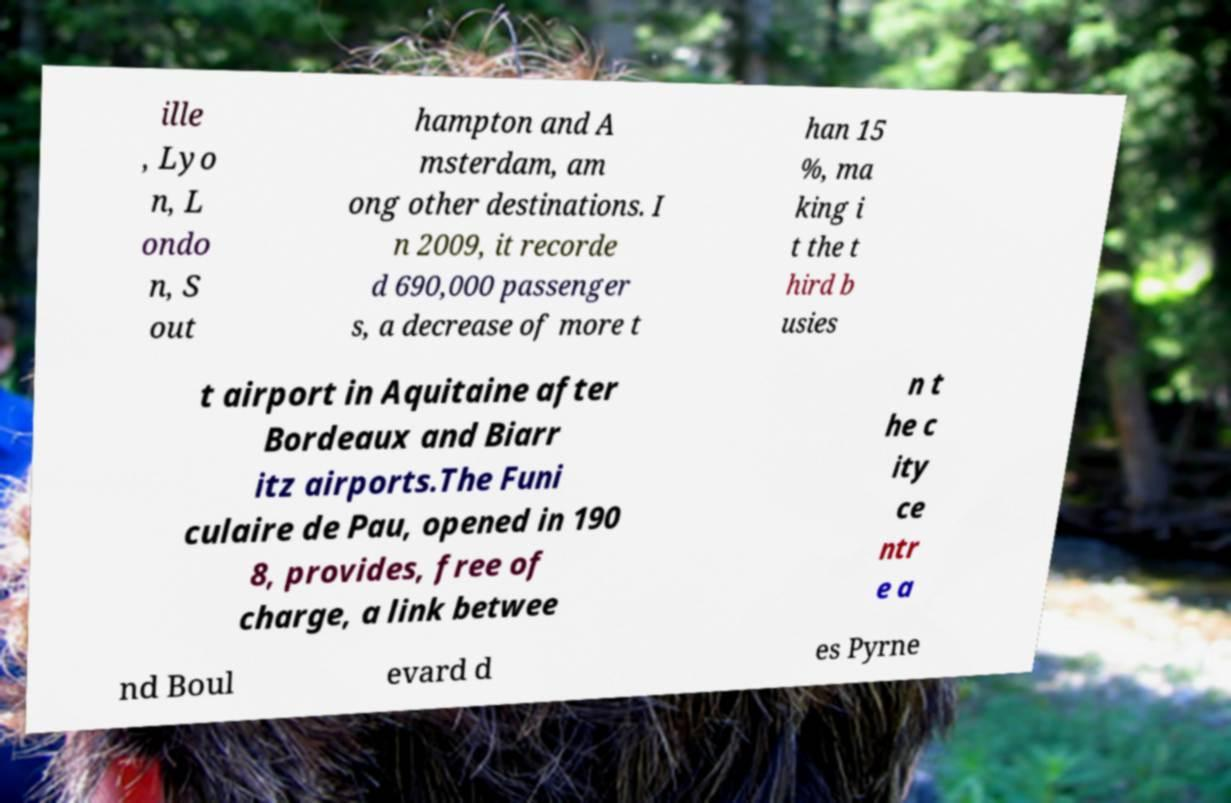I need the written content from this picture converted into text. Can you do that? ille , Lyo n, L ondo n, S out hampton and A msterdam, am ong other destinations. I n 2009, it recorde d 690,000 passenger s, a decrease of more t han 15 %, ma king i t the t hird b usies t airport in Aquitaine after Bordeaux and Biarr itz airports.The Funi culaire de Pau, opened in 190 8, provides, free of charge, a link betwee n t he c ity ce ntr e a nd Boul evard d es Pyrne 